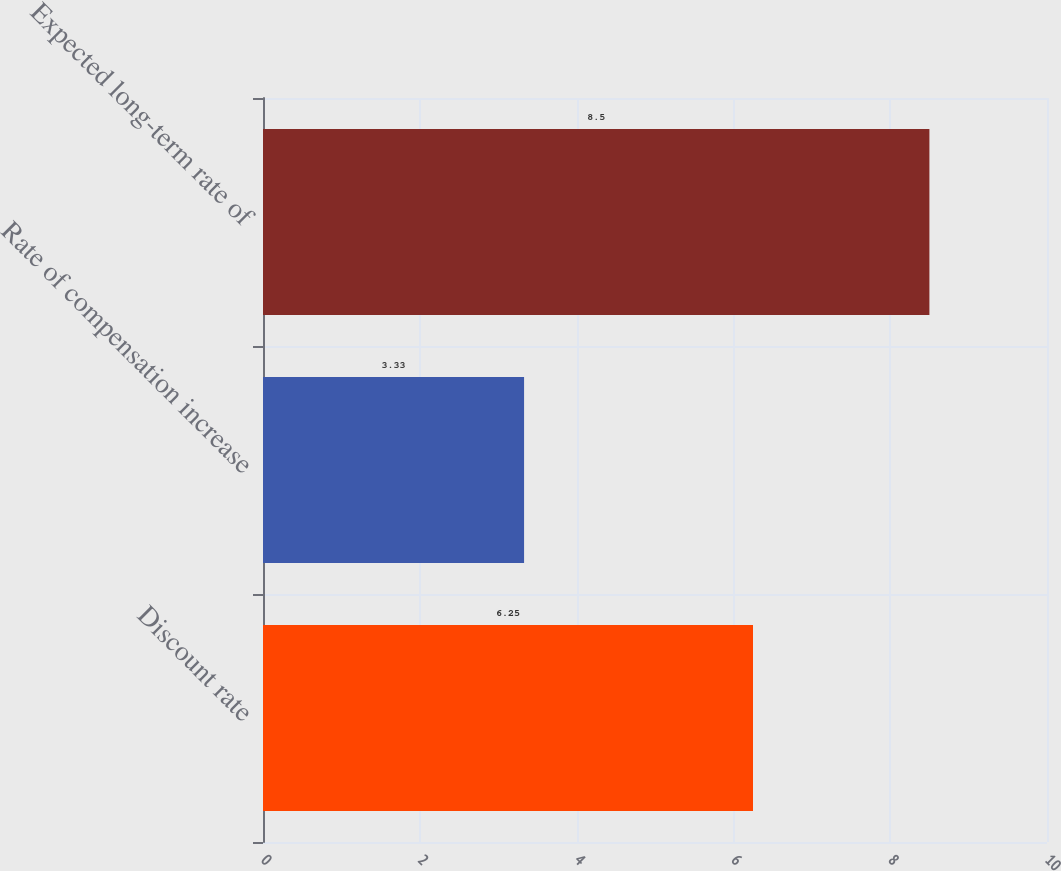Convert chart to OTSL. <chart><loc_0><loc_0><loc_500><loc_500><bar_chart><fcel>Discount rate<fcel>Rate of compensation increase<fcel>Expected long-term rate of<nl><fcel>6.25<fcel>3.33<fcel>8.5<nl></chart> 